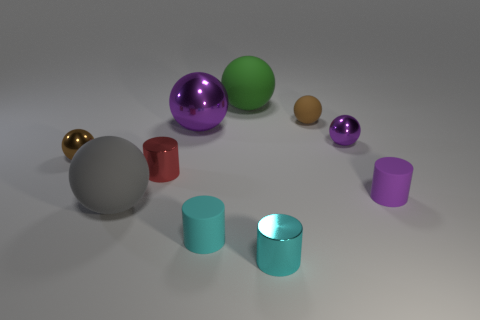Subtract all large shiny balls. How many balls are left? 5 Subtract all gray blocks. How many brown balls are left? 2 Subtract all green balls. How many balls are left? 5 Subtract 1 balls. How many balls are left? 5 Subtract all yellow cylinders. Subtract all cyan spheres. How many cylinders are left? 4 Subtract all cylinders. How many objects are left? 6 Add 2 tiny rubber cylinders. How many tiny rubber cylinders are left? 4 Add 5 large metallic things. How many large metallic things exist? 6 Subtract 2 cyan cylinders. How many objects are left? 8 Subtract all large cyan matte cubes. Subtract all shiny balls. How many objects are left? 7 